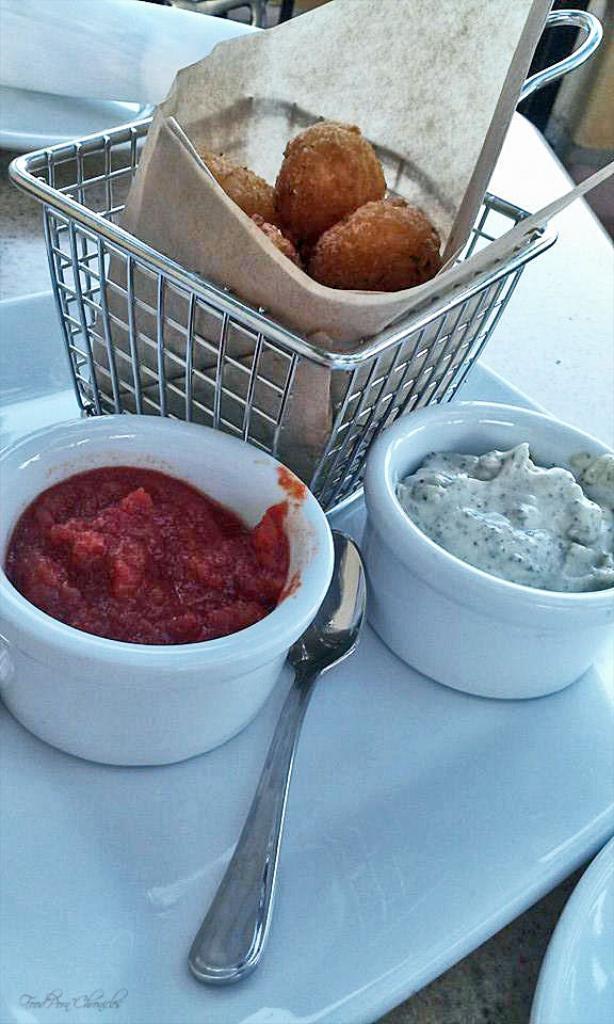Please provide a concise description of this image. In this image we can see a serving plate which has nuggets in the bucket, dips in the bowls and a spoon. 